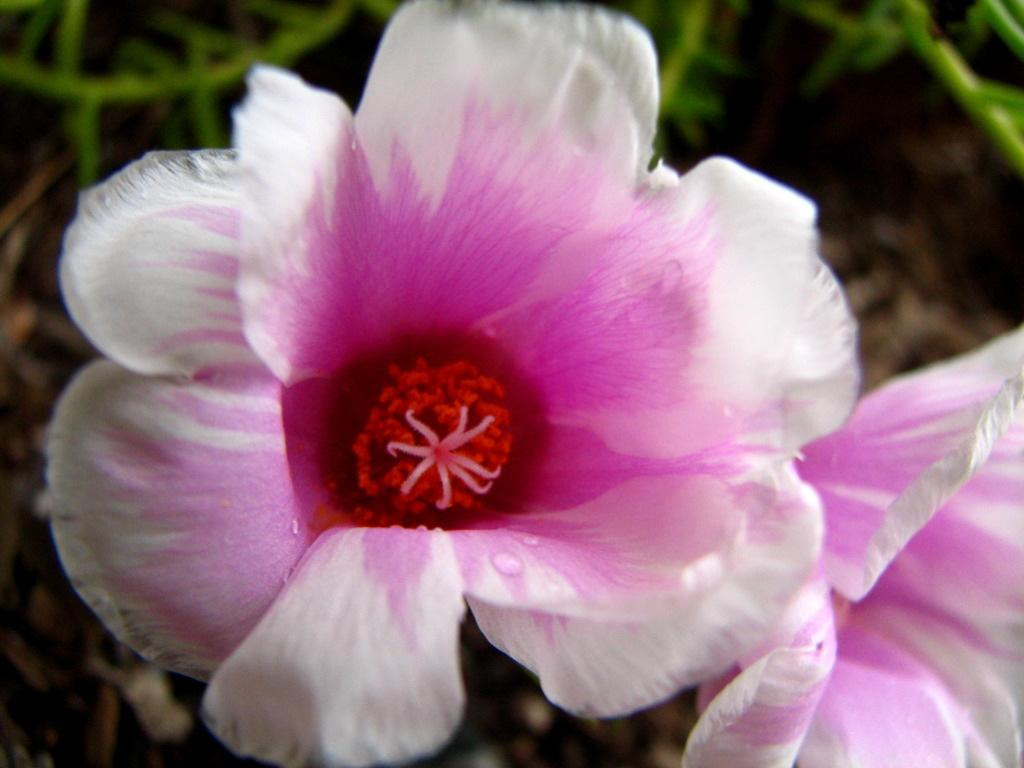What type of living organisms can be seen in the image? The image contains flowers. What colors are the flowers in the image? The flowers are in white and pink colors. What else can be seen in the background of the image? There are plants in the background of the image. How is the background of the image depicted? The background is blurred. How does the image depict an increase in the number of flowers over time? The image does not depict an increase in the number of flowers over time; it shows a static scene with flowers in white and pink colors. 